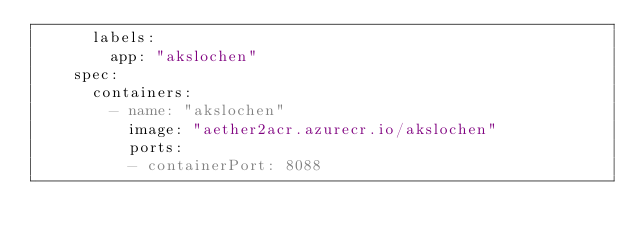Convert code to text. <code><loc_0><loc_0><loc_500><loc_500><_YAML_>      labels:
        app: "akslochen"
    spec:
      containers:
        - name: "akslochen"
          image: "aether2acr.azurecr.io/akslochen"
          ports:
          - containerPort: 8088</code> 